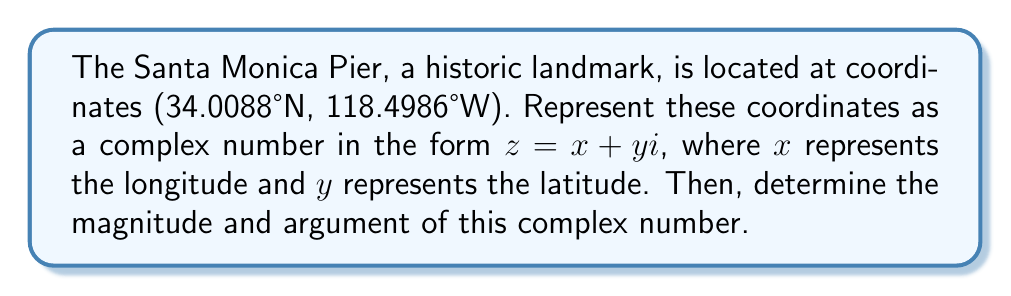Help me with this question. 1) First, let's represent the coordinates as a complex number:
   $z = -118.4986 + 34.0088i$

2) To find the magnitude, we use the formula:
   $|z| = \sqrt{x^2 + y^2}$
   
   $|z| = \sqrt{(-118.4986)^2 + (34.0088)^2}$
   $|z| = \sqrt{14021.9020 + 1156.5984}$
   $|z| = \sqrt{15178.5004}$
   $|z| \approx 123.2011$

3) To find the argument, we use the formula:
   $\arg(z) = \tan^{-1}(\frac{y}{x})$

   However, since $x$ is negative and $y$ is positive, we need to add $\pi$ to the result:
   
   $\arg(z) = \tan^{-1}(\frac{34.0088}{-118.4986}) + \pi$
   $\arg(z) = -0.2790 + \pi$
   $\arg(z) \approx 2.8626$ radians

4) Converting the argument to degrees:
   $\arg(z) \approx 2.8626 \times \frac{180}{\pi} \approx 164.0018°$
Answer: Magnitude: $123.2011$, Argument: $2.8626$ radians or $164.0018°$ 